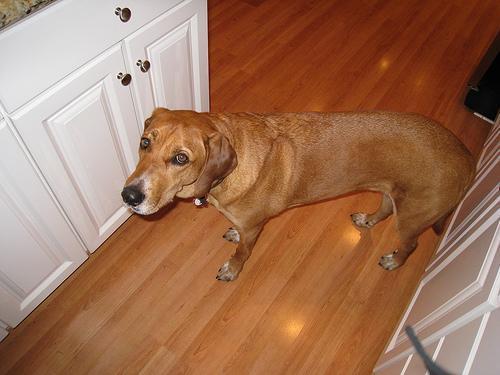How many dogs are there?
Give a very brief answer. 1. 